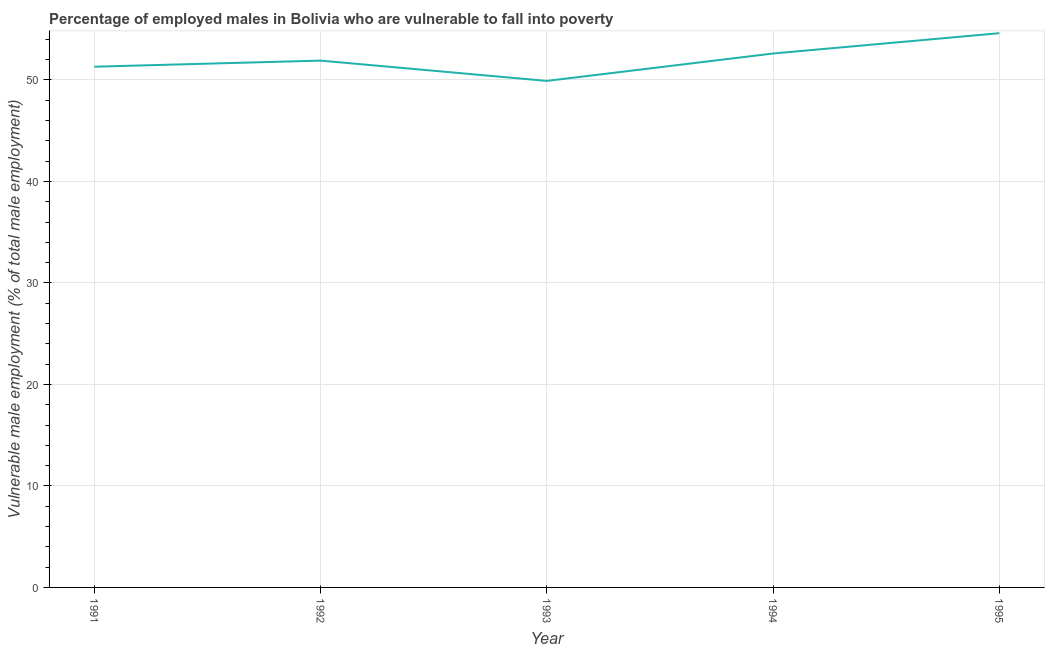What is the percentage of employed males who are vulnerable to fall into poverty in 1991?
Your answer should be very brief. 51.3. Across all years, what is the maximum percentage of employed males who are vulnerable to fall into poverty?
Offer a very short reply. 54.6. Across all years, what is the minimum percentage of employed males who are vulnerable to fall into poverty?
Your response must be concise. 49.9. In which year was the percentage of employed males who are vulnerable to fall into poverty minimum?
Provide a succinct answer. 1993. What is the sum of the percentage of employed males who are vulnerable to fall into poverty?
Ensure brevity in your answer.  260.3. What is the average percentage of employed males who are vulnerable to fall into poverty per year?
Make the answer very short. 52.06. What is the median percentage of employed males who are vulnerable to fall into poverty?
Keep it short and to the point. 51.9. In how many years, is the percentage of employed males who are vulnerable to fall into poverty greater than 6 %?
Offer a terse response. 5. Do a majority of the years between 1995 and 1991 (inclusive) have percentage of employed males who are vulnerable to fall into poverty greater than 2 %?
Keep it short and to the point. Yes. What is the ratio of the percentage of employed males who are vulnerable to fall into poverty in 1991 to that in 1993?
Provide a succinct answer. 1.03. Is the percentage of employed males who are vulnerable to fall into poverty in 1992 less than that in 1995?
Offer a very short reply. Yes. Is the difference between the percentage of employed males who are vulnerable to fall into poverty in 1992 and 1994 greater than the difference between any two years?
Ensure brevity in your answer.  No. What is the difference between the highest and the second highest percentage of employed males who are vulnerable to fall into poverty?
Ensure brevity in your answer.  2. What is the difference between the highest and the lowest percentage of employed males who are vulnerable to fall into poverty?
Offer a very short reply. 4.7. How many years are there in the graph?
Give a very brief answer. 5. What is the difference between two consecutive major ticks on the Y-axis?
Your answer should be compact. 10. Are the values on the major ticks of Y-axis written in scientific E-notation?
Ensure brevity in your answer.  No. Does the graph contain any zero values?
Provide a succinct answer. No. Does the graph contain grids?
Keep it short and to the point. Yes. What is the title of the graph?
Offer a terse response. Percentage of employed males in Bolivia who are vulnerable to fall into poverty. What is the label or title of the Y-axis?
Provide a short and direct response. Vulnerable male employment (% of total male employment). What is the Vulnerable male employment (% of total male employment) in 1991?
Provide a succinct answer. 51.3. What is the Vulnerable male employment (% of total male employment) of 1992?
Make the answer very short. 51.9. What is the Vulnerable male employment (% of total male employment) in 1993?
Offer a terse response. 49.9. What is the Vulnerable male employment (% of total male employment) in 1994?
Ensure brevity in your answer.  52.6. What is the Vulnerable male employment (% of total male employment) in 1995?
Offer a terse response. 54.6. What is the difference between the Vulnerable male employment (% of total male employment) in 1991 and 1992?
Provide a succinct answer. -0.6. What is the difference between the Vulnerable male employment (% of total male employment) in 1991 and 1994?
Offer a terse response. -1.3. What is the difference between the Vulnerable male employment (% of total male employment) in 1991 and 1995?
Provide a succinct answer. -3.3. What is the difference between the Vulnerable male employment (% of total male employment) in 1992 and 1994?
Offer a terse response. -0.7. What is the difference between the Vulnerable male employment (% of total male employment) in 1992 and 1995?
Keep it short and to the point. -2.7. What is the difference between the Vulnerable male employment (% of total male employment) in 1993 and 1994?
Ensure brevity in your answer.  -2.7. What is the ratio of the Vulnerable male employment (% of total male employment) in 1991 to that in 1993?
Ensure brevity in your answer.  1.03. What is the ratio of the Vulnerable male employment (% of total male employment) in 1991 to that in 1994?
Give a very brief answer. 0.97. What is the ratio of the Vulnerable male employment (% of total male employment) in 1992 to that in 1993?
Ensure brevity in your answer.  1.04. What is the ratio of the Vulnerable male employment (% of total male employment) in 1992 to that in 1994?
Your answer should be very brief. 0.99. What is the ratio of the Vulnerable male employment (% of total male employment) in 1992 to that in 1995?
Provide a succinct answer. 0.95. What is the ratio of the Vulnerable male employment (% of total male employment) in 1993 to that in 1994?
Provide a succinct answer. 0.95. What is the ratio of the Vulnerable male employment (% of total male employment) in 1993 to that in 1995?
Provide a short and direct response. 0.91. 